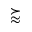<formula> <loc_0><loc_0><loc_500><loc_500>\succ a p p r o x</formula> 